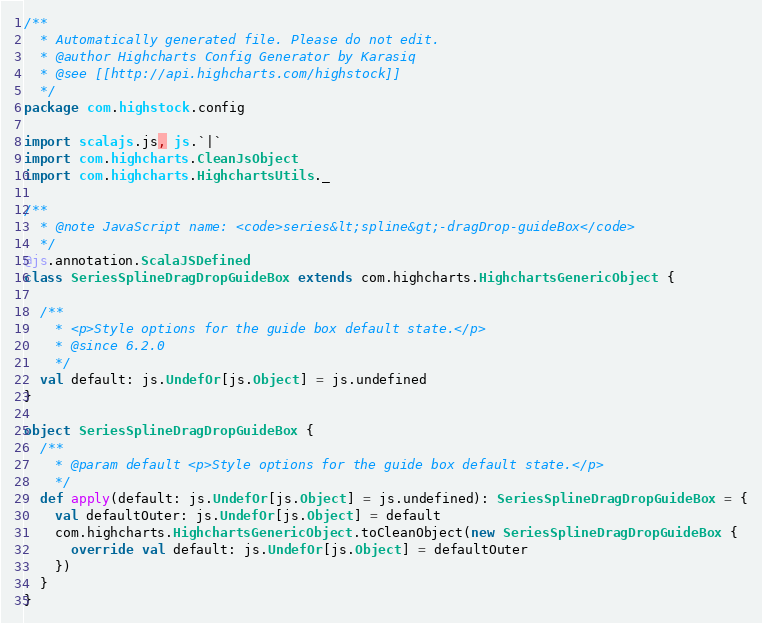<code> <loc_0><loc_0><loc_500><loc_500><_Scala_>/**
  * Automatically generated file. Please do not edit.
  * @author Highcharts Config Generator by Karasiq
  * @see [[http://api.highcharts.com/highstock]]
  */
package com.highstock.config

import scalajs.js, js.`|`
import com.highcharts.CleanJsObject
import com.highcharts.HighchartsUtils._

/**
  * @note JavaScript name: <code>series&lt;spline&gt;-dragDrop-guideBox</code>
  */
@js.annotation.ScalaJSDefined
class SeriesSplineDragDropGuideBox extends com.highcharts.HighchartsGenericObject {

  /**
    * <p>Style options for the guide box default state.</p>
    * @since 6.2.0
    */
  val default: js.UndefOr[js.Object] = js.undefined
}

object SeriesSplineDragDropGuideBox {
  /**
    * @param default <p>Style options for the guide box default state.</p>
    */
  def apply(default: js.UndefOr[js.Object] = js.undefined): SeriesSplineDragDropGuideBox = {
    val defaultOuter: js.UndefOr[js.Object] = default
    com.highcharts.HighchartsGenericObject.toCleanObject(new SeriesSplineDragDropGuideBox {
      override val default: js.UndefOr[js.Object] = defaultOuter
    })
  }
}
</code> 